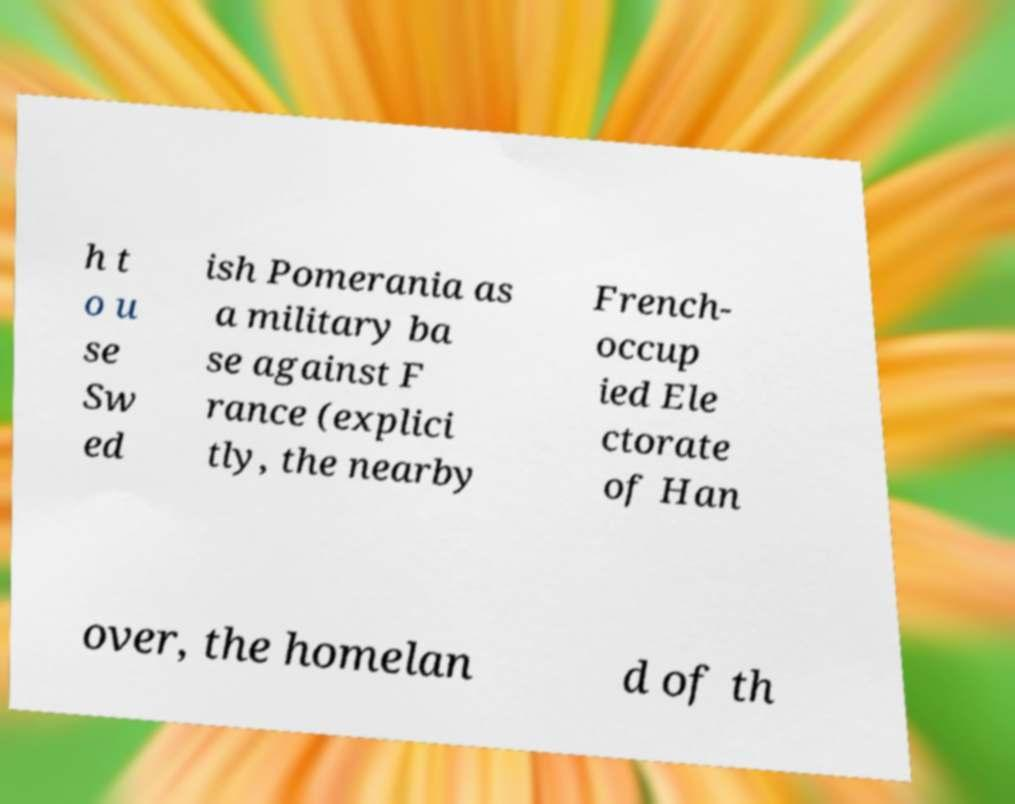Can you accurately transcribe the text from the provided image for me? h t o u se Sw ed ish Pomerania as a military ba se against F rance (explici tly, the nearby French- occup ied Ele ctorate of Han over, the homelan d of th 